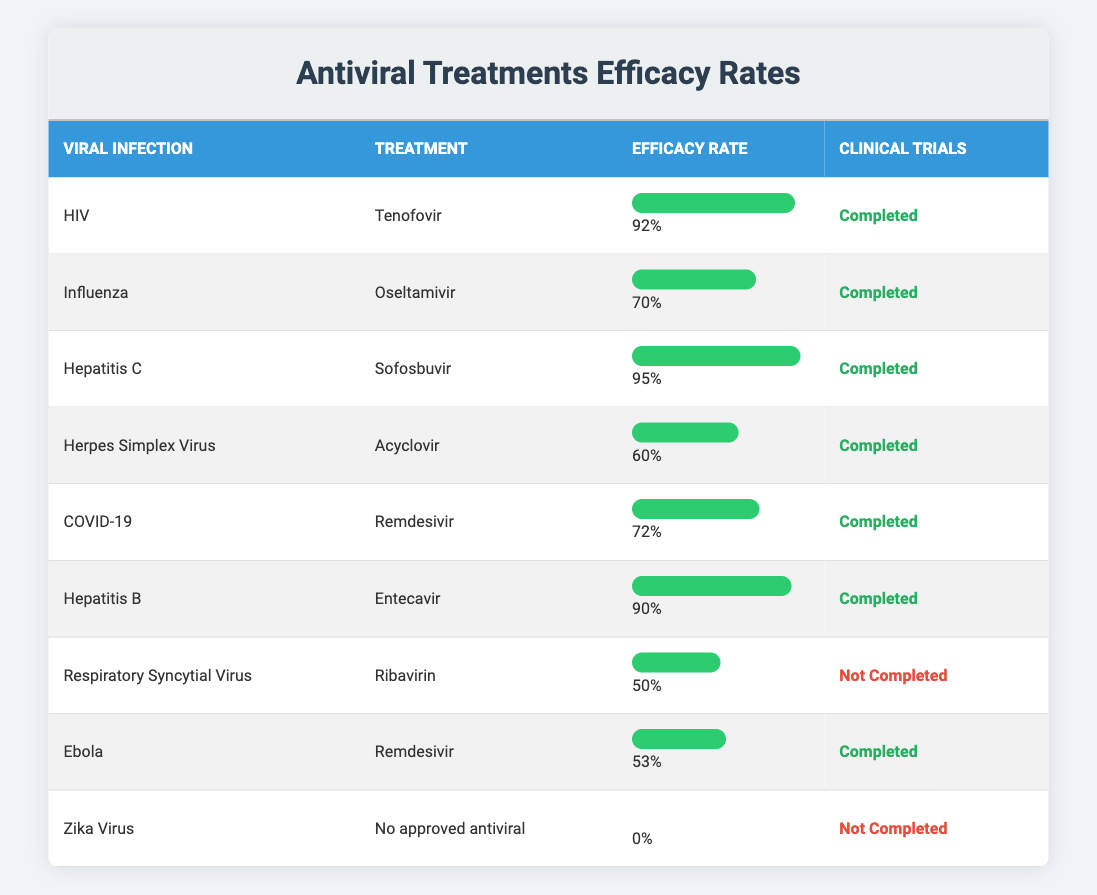What is the efficacy rate of Tenofovir for HIV? From the table, Tenofovir is the treatment for HIV, and its efficacy rate is stated to be 92%.
Answer: 92% Which antiviral treatment has the highest efficacy rate? The efficacy rates in the table can be viewed to find the maximum value. Sofosbuvir for Hepatitis C has the highest efficacy rate at 95%.
Answer: 95% Have clinical trials been completed for Oseltamivir? The table indicates that clinical trials for Oseltamivir, which is used for Influenza, have been completed as it states "Completed".
Answer: Yes How many antiviral treatments have completed clinical trials? By reviewing the table, we can count the treatments that have "Completed" under the clinical trials column. There are six treatments (Tenofovir, Oseltamivir, Sofosbuvir, Acyclovir, Remdesivir for COVID-19, and Entecavir).
Answer: 6 What is the average efficacy rate of the treatments listed for completed clinical trials? First, sum the efficacy rates of the completed trials: 92 + 70 + 95 + 60 + 72 + 90 = 479. Then, divide that sum by the number of treatments with completed trials (6): 479/6 = 79.83.
Answer: Approximately 79.83 Is there a treatment with an efficacy rate of 0% and also not completed clinical trials? According to the table, Zika Virus has no approved antiviral treatment with an efficacy rate of 0% and it has not completed clinical trials, thus confirming the statement is true.
Answer: Yes What is the difference in efficacy rates between Sofosbuvir and Acyclovir? The efficacy rate for Sofosbuvir is 95% and for Acyclovir, it is 60%. The difference is 95 - 60 = 35%.
Answer: 35% For which viral infection do we have no approved antiviral treatment? According to the table, the Zika Virus is noted to have "No approved antiviral" indicating that there is no effective treatment categorized.
Answer: Zika Virus Which treatment has the lowest efficacy rate that has completed clinical trials? Reviewing the efficacy rates for the treatments with completed clinical trials, Acyclovir for Herpes Simplex Virus has the lowest efficacy rate of 60%.
Answer: 60% 